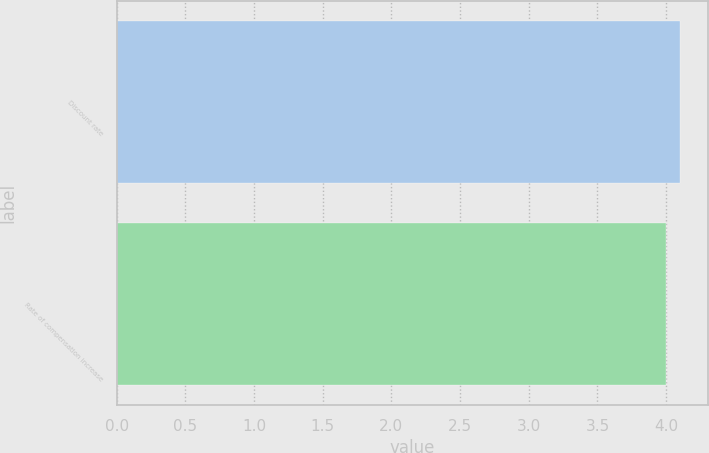Convert chart. <chart><loc_0><loc_0><loc_500><loc_500><bar_chart><fcel>Discount rate<fcel>Rate of compensation increase<nl><fcel>4.1<fcel>4<nl></chart> 